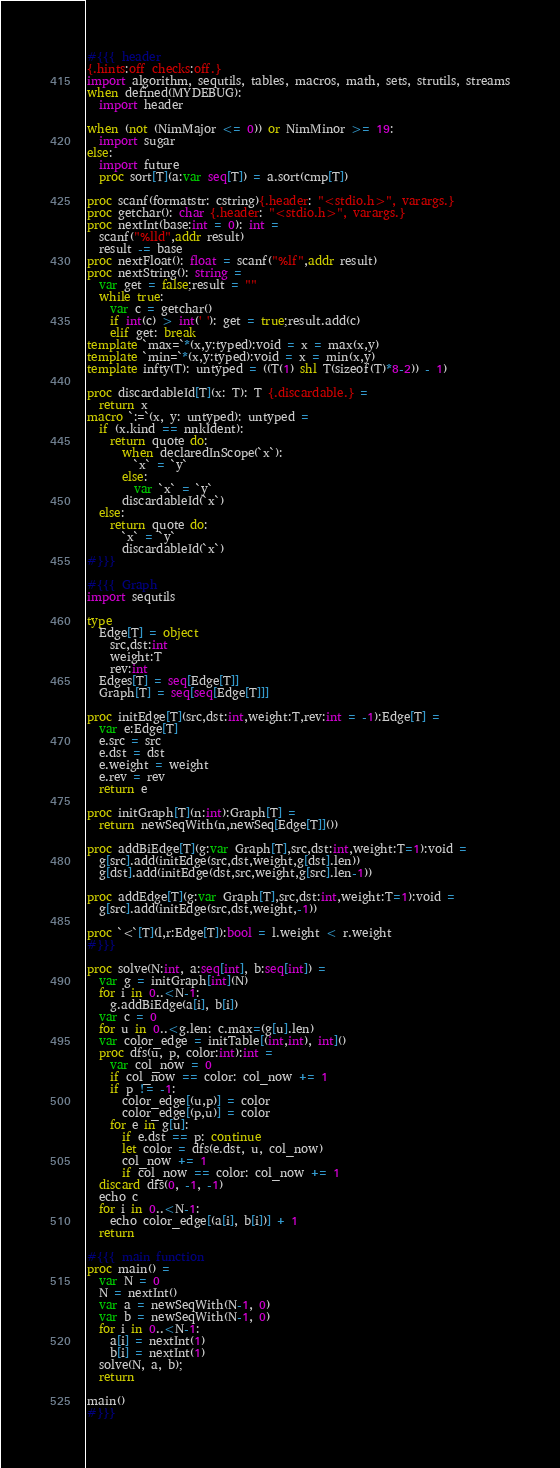Convert code to text. <code><loc_0><loc_0><loc_500><loc_500><_Nim_>#{{{ header
{.hints:off checks:off.}
import algorithm, sequtils, tables, macros, math, sets, strutils, streams
when defined(MYDEBUG):
  import header

when (not (NimMajor <= 0)) or NimMinor >= 19:
  import sugar
else:
  import future
  proc sort[T](a:var seq[T]) = a.sort(cmp[T])

proc scanf(formatstr: cstring){.header: "<stdio.h>", varargs.}
proc getchar(): char {.header: "<stdio.h>", varargs.}
proc nextInt(base:int = 0): int =
  scanf("%lld",addr result)
  result -= base
proc nextFloat(): float = scanf("%lf",addr result)
proc nextString(): string =
  var get = false;result = ""
  while true:
    var c = getchar()
    if int(c) > int(' '): get = true;result.add(c)
    elif get: break
template `max=`*(x,y:typed):void = x = max(x,y)
template `min=`*(x,y:typed):void = x = min(x,y)
template infty(T): untyped = ((T(1) shl T(sizeof(T)*8-2)) - 1)

proc discardableId[T](x: T): T {.discardable.} =
  return x
macro `:=`(x, y: untyped): untyped =
  if (x.kind == nnkIdent):
    return quote do:
      when declaredInScope(`x`):
        `x` = `y`
      else:
        var `x` = `y`
      discardableId(`x`)
  else:
    return quote do:
      `x` = `y`
      discardableId(`x`)
#}}}

#{{{ Graph
import sequtils

type
  Edge[T] = object
    src,dst:int
    weight:T
    rev:int
  Edges[T] = seq[Edge[T]]
  Graph[T] = seq[seq[Edge[T]]]

proc initEdge[T](src,dst:int,weight:T,rev:int = -1):Edge[T] =
  var e:Edge[T]
  e.src = src
  e.dst = dst
  e.weight = weight
  e.rev = rev
  return e

proc initGraph[T](n:int):Graph[T] =
  return newSeqWith(n,newSeq[Edge[T]]())

proc addBiEdge[T](g:var Graph[T],src,dst:int,weight:T=1):void =
  g[src].add(initEdge(src,dst,weight,g[dst].len))
  g[dst].add(initEdge(dst,src,weight,g[src].len-1))

proc addEdge[T](g:var Graph[T],src,dst:int,weight:T=1):void =
  g[src].add(initEdge(src,dst,weight,-1))

proc `<`[T](l,r:Edge[T]):bool = l.weight < r.weight
#}}}

proc solve(N:int, a:seq[int], b:seq[int]) =
  var g = initGraph[int](N)
  for i in 0..<N-1:
    g.addBiEdge(a[i], b[i])
  var c = 0
  for u in 0..<g.len: c.max=(g[u].len)
  var color_edge = initTable[(int,int), int]()
  proc dfs(u, p, color:int):int =
    var col_now = 0
    if col_now == color: col_now += 1
    if p != -1:
      color_edge[(u,p)] = color
      color_edge[(p,u)] = color
    for e in g[u]:
      if e.dst == p: continue
      let color = dfs(e.dst, u, col_now)
      col_now += 1
      if col_now == color: col_now += 1
  discard dfs(0, -1, -1)
  echo c
  for i in 0..<N-1:
    echo color_edge[(a[i], b[i])] + 1
  return

#{{{ main function
proc main() =
  var N = 0
  N = nextInt()
  var a = newSeqWith(N-1, 0)
  var b = newSeqWith(N-1, 0)
  for i in 0..<N-1:
    a[i] = nextInt(1)
    b[i] = nextInt(1)
  solve(N, a, b);
  return

main()
#}}}</code> 